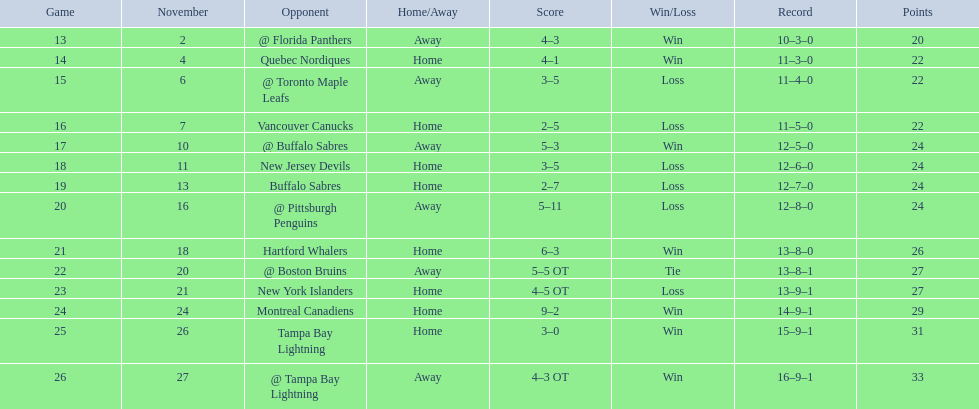What are the teams in the atlantic division? Quebec Nordiques, Vancouver Canucks, New Jersey Devils, Buffalo Sabres, Hartford Whalers, New York Islanders, Montreal Canadiens, Tampa Bay Lightning. Which of those scored fewer points than the philadelphia flyers? Tampa Bay Lightning. 